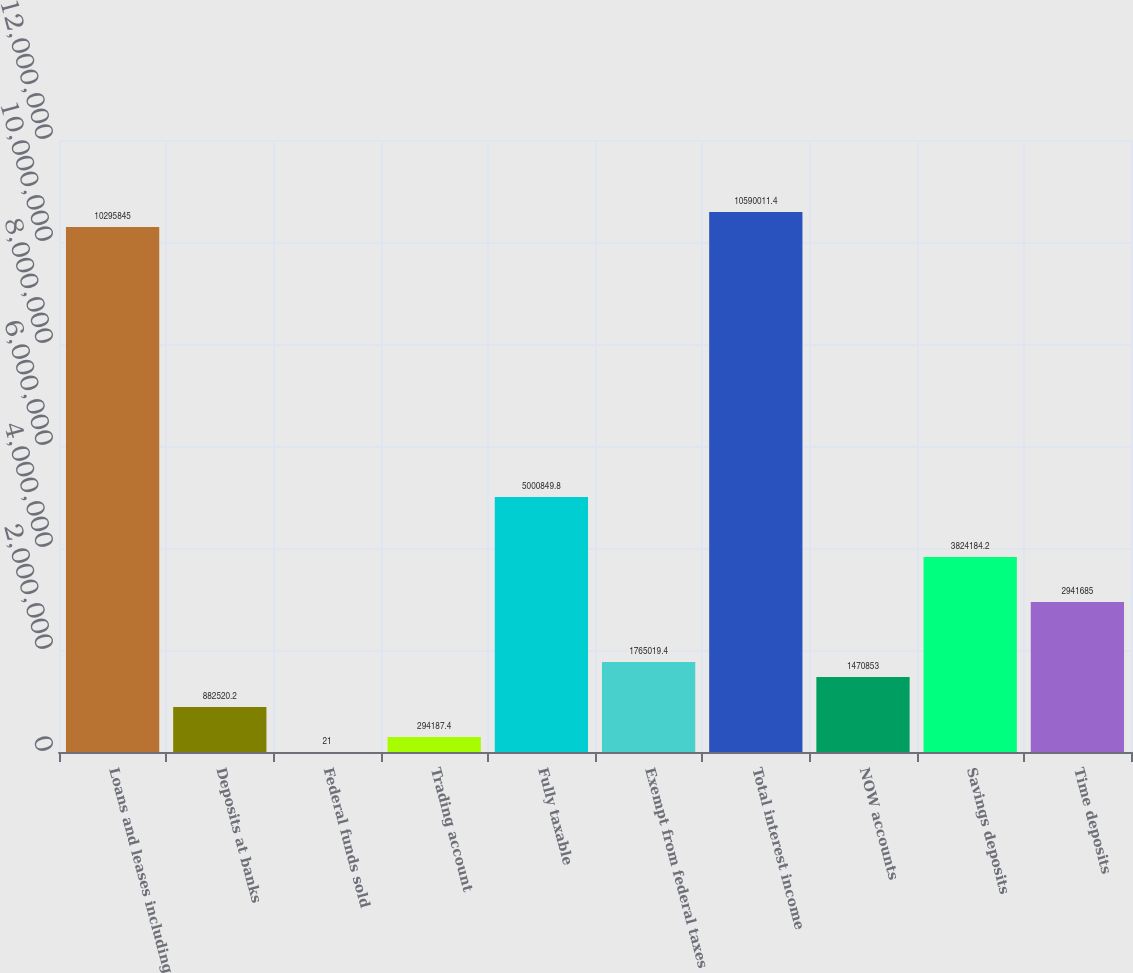Convert chart to OTSL. <chart><loc_0><loc_0><loc_500><loc_500><bar_chart><fcel>Loans and leases including<fcel>Deposits at banks<fcel>Federal funds sold<fcel>Trading account<fcel>Fully taxable<fcel>Exempt from federal taxes<fcel>Total interest income<fcel>NOW accounts<fcel>Savings deposits<fcel>Time deposits<nl><fcel>1.02958e+07<fcel>882520<fcel>21<fcel>294187<fcel>5.00085e+06<fcel>1.76502e+06<fcel>1.059e+07<fcel>1.47085e+06<fcel>3.82418e+06<fcel>2.94168e+06<nl></chart> 